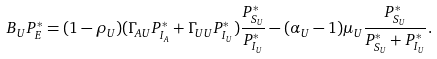Convert formula to latex. <formula><loc_0><loc_0><loc_500><loc_500>B _ { U } P ^ { * } _ { E } = ( 1 - \rho _ { U } ) ( \Gamma _ { A U } P ^ { * } _ { I _ { A } } + \Gamma _ { U U } P ^ { * } _ { I _ { U } } ) \frac { P ^ { * } _ { S _ { U } } } { P ^ { * } _ { I _ { U } } } - ( \alpha _ { U } - 1 ) \mu _ { U } \frac { P ^ { * } _ { S _ { U } } } { P ^ { * } _ { S _ { U } } + P ^ { * } _ { I _ { U } } } .</formula> 